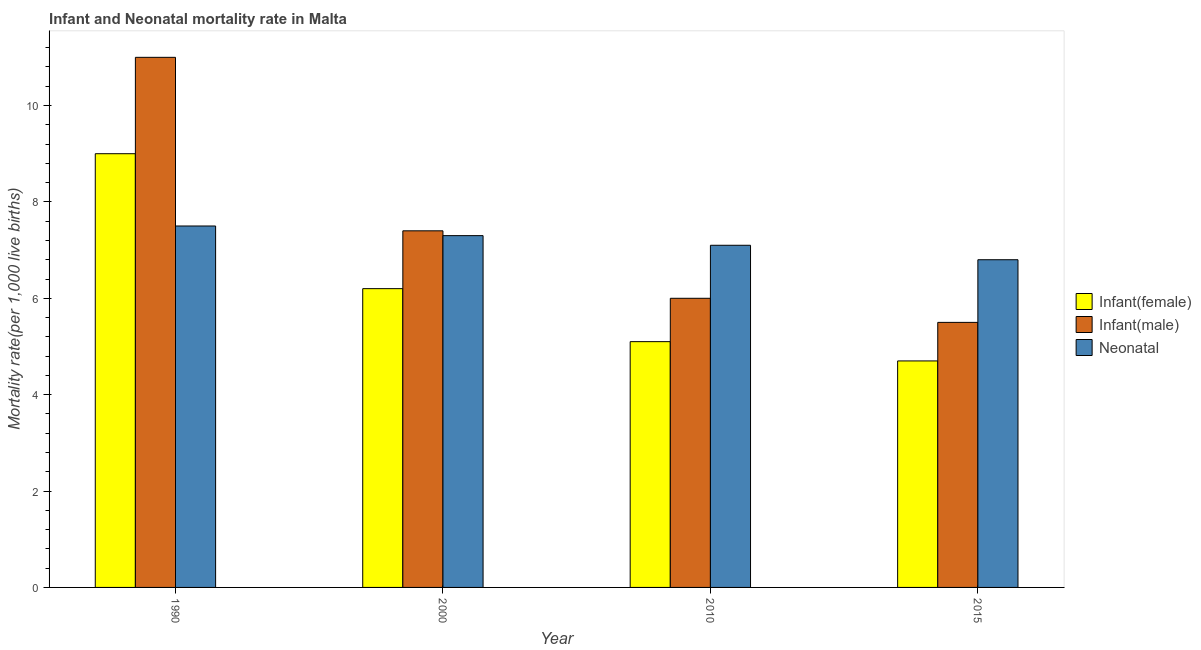How many groups of bars are there?
Make the answer very short. 4. Are the number of bars on each tick of the X-axis equal?
Offer a very short reply. Yes. How many bars are there on the 3rd tick from the right?
Make the answer very short. 3. What is the label of the 2nd group of bars from the left?
Make the answer very short. 2000. Across all years, what is the maximum infant mortality rate(female)?
Make the answer very short. 9. In which year was the infant mortality rate(male) minimum?
Your answer should be compact. 2015. What is the total neonatal mortality rate in the graph?
Give a very brief answer. 28.7. What is the difference between the infant mortality rate(male) in 2000 and that in 2015?
Give a very brief answer. 1.9. What is the difference between the neonatal mortality rate in 2000 and the infant mortality rate(male) in 1990?
Offer a very short reply. -0.2. What is the average infant mortality rate(male) per year?
Ensure brevity in your answer.  7.47. In the year 1990, what is the difference between the neonatal mortality rate and infant mortality rate(female)?
Give a very brief answer. 0. What is the ratio of the neonatal mortality rate in 1990 to that in 2000?
Give a very brief answer. 1.03. Is the infant mortality rate(female) in 1990 less than that in 2000?
Provide a short and direct response. No. What is the difference between the highest and the second highest neonatal mortality rate?
Provide a short and direct response. 0.2. What is the difference between the highest and the lowest infant mortality rate(male)?
Offer a terse response. 5.5. In how many years, is the infant mortality rate(female) greater than the average infant mortality rate(female) taken over all years?
Ensure brevity in your answer.  1. Is the sum of the neonatal mortality rate in 1990 and 2010 greater than the maximum infant mortality rate(female) across all years?
Your answer should be compact. Yes. What does the 2nd bar from the left in 2015 represents?
Offer a terse response. Infant(male). What does the 1st bar from the right in 2000 represents?
Offer a terse response. Neonatal . Are all the bars in the graph horizontal?
Give a very brief answer. No. How many years are there in the graph?
Your answer should be compact. 4. What is the difference between two consecutive major ticks on the Y-axis?
Give a very brief answer. 2. Are the values on the major ticks of Y-axis written in scientific E-notation?
Give a very brief answer. No. Does the graph contain any zero values?
Your answer should be compact. No. Does the graph contain grids?
Provide a succinct answer. No. Where does the legend appear in the graph?
Your answer should be very brief. Center right. How many legend labels are there?
Provide a short and direct response. 3. How are the legend labels stacked?
Offer a very short reply. Vertical. What is the title of the graph?
Give a very brief answer. Infant and Neonatal mortality rate in Malta. Does "Agricultural Nitrous Oxide" appear as one of the legend labels in the graph?
Offer a terse response. No. What is the label or title of the X-axis?
Provide a short and direct response. Year. What is the label or title of the Y-axis?
Ensure brevity in your answer.  Mortality rate(per 1,0 live births). What is the Mortality rate(per 1,000 live births) in Infant(male) in 1990?
Give a very brief answer. 11. What is the Mortality rate(per 1,000 live births) of Infant(male) in 2000?
Your response must be concise. 7.4. What is the Mortality rate(per 1,000 live births) of Neonatal  in 2000?
Give a very brief answer. 7.3. What is the Mortality rate(per 1,000 live births) of Infant(female) in 2010?
Your answer should be compact. 5.1. What is the Mortality rate(per 1,000 live births) in Infant(female) in 2015?
Your answer should be compact. 4.7. What is the Mortality rate(per 1,000 live births) of Infant(male) in 2015?
Your response must be concise. 5.5. What is the Mortality rate(per 1,000 live births) of Neonatal  in 2015?
Provide a short and direct response. 6.8. Across all years, what is the minimum Mortality rate(per 1,000 live births) in Infant(male)?
Ensure brevity in your answer.  5.5. Across all years, what is the minimum Mortality rate(per 1,000 live births) in Neonatal ?
Keep it short and to the point. 6.8. What is the total Mortality rate(per 1,000 live births) of Infant(male) in the graph?
Provide a succinct answer. 29.9. What is the total Mortality rate(per 1,000 live births) in Neonatal  in the graph?
Make the answer very short. 28.7. What is the difference between the Mortality rate(per 1,000 live births) of Infant(male) in 1990 and that in 2000?
Give a very brief answer. 3.6. What is the difference between the Mortality rate(per 1,000 live births) of Infant(female) in 1990 and that in 2010?
Offer a terse response. 3.9. What is the difference between the Mortality rate(per 1,000 live births) in Infant(male) in 1990 and that in 2010?
Provide a succinct answer. 5. What is the difference between the Mortality rate(per 1,000 live births) of Infant(female) in 1990 and that in 2015?
Provide a succinct answer. 4.3. What is the difference between the Mortality rate(per 1,000 live births) in Infant(male) in 1990 and that in 2015?
Ensure brevity in your answer.  5.5. What is the difference between the Mortality rate(per 1,000 live births) of Neonatal  in 1990 and that in 2015?
Keep it short and to the point. 0.7. What is the difference between the Mortality rate(per 1,000 live births) of Infant(female) in 2000 and that in 2010?
Give a very brief answer. 1.1. What is the difference between the Mortality rate(per 1,000 live births) of Neonatal  in 2000 and that in 2010?
Offer a terse response. 0.2. What is the difference between the Mortality rate(per 1,000 live births) of Infant(male) in 2000 and that in 2015?
Your response must be concise. 1.9. What is the difference between the Mortality rate(per 1,000 live births) of Neonatal  in 2010 and that in 2015?
Your answer should be very brief. 0.3. What is the difference between the Mortality rate(per 1,000 live births) of Infant(female) in 1990 and the Mortality rate(per 1,000 live births) of Infant(male) in 2000?
Provide a short and direct response. 1.6. What is the difference between the Mortality rate(per 1,000 live births) of Infant(female) in 1990 and the Mortality rate(per 1,000 live births) of Infant(male) in 2015?
Provide a succinct answer. 3.5. What is the difference between the Mortality rate(per 1,000 live births) of Infant(female) in 1990 and the Mortality rate(per 1,000 live births) of Neonatal  in 2015?
Provide a short and direct response. 2.2. What is the difference between the Mortality rate(per 1,000 live births) of Infant(male) in 2000 and the Mortality rate(per 1,000 live births) of Neonatal  in 2015?
Provide a succinct answer. 0.6. What is the difference between the Mortality rate(per 1,000 live births) in Infant(female) in 2010 and the Mortality rate(per 1,000 live births) in Neonatal  in 2015?
Give a very brief answer. -1.7. What is the average Mortality rate(per 1,000 live births) in Infant(female) per year?
Your answer should be very brief. 6.25. What is the average Mortality rate(per 1,000 live births) in Infant(male) per year?
Keep it short and to the point. 7.47. What is the average Mortality rate(per 1,000 live births) of Neonatal  per year?
Make the answer very short. 7.17. In the year 1990, what is the difference between the Mortality rate(per 1,000 live births) in Infant(female) and Mortality rate(per 1,000 live births) in Neonatal ?
Make the answer very short. 1.5. In the year 2000, what is the difference between the Mortality rate(per 1,000 live births) in Infant(female) and Mortality rate(per 1,000 live births) in Neonatal ?
Make the answer very short. -1.1. In the year 2010, what is the difference between the Mortality rate(per 1,000 live births) in Infant(female) and Mortality rate(per 1,000 live births) in Infant(male)?
Your response must be concise. -0.9. In the year 2010, what is the difference between the Mortality rate(per 1,000 live births) in Infant(female) and Mortality rate(per 1,000 live births) in Neonatal ?
Make the answer very short. -2. In the year 2015, what is the difference between the Mortality rate(per 1,000 live births) in Infant(male) and Mortality rate(per 1,000 live births) in Neonatal ?
Offer a very short reply. -1.3. What is the ratio of the Mortality rate(per 1,000 live births) of Infant(female) in 1990 to that in 2000?
Your response must be concise. 1.45. What is the ratio of the Mortality rate(per 1,000 live births) in Infant(male) in 1990 to that in 2000?
Keep it short and to the point. 1.49. What is the ratio of the Mortality rate(per 1,000 live births) in Neonatal  in 1990 to that in 2000?
Your answer should be very brief. 1.03. What is the ratio of the Mortality rate(per 1,000 live births) in Infant(female) in 1990 to that in 2010?
Give a very brief answer. 1.76. What is the ratio of the Mortality rate(per 1,000 live births) of Infant(male) in 1990 to that in 2010?
Offer a terse response. 1.83. What is the ratio of the Mortality rate(per 1,000 live births) of Neonatal  in 1990 to that in 2010?
Your response must be concise. 1.06. What is the ratio of the Mortality rate(per 1,000 live births) of Infant(female) in 1990 to that in 2015?
Provide a succinct answer. 1.91. What is the ratio of the Mortality rate(per 1,000 live births) in Neonatal  in 1990 to that in 2015?
Provide a short and direct response. 1.1. What is the ratio of the Mortality rate(per 1,000 live births) of Infant(female) in 2000 to that in 2010?
Offer a very short reply. 1.22. What is the ratio of the Mortality rate(per 1,000 live births) in Infant(male) in 2000 to that in 2010?
Make the answer very short. 1.23. What is the ratio of the Mortality rate(per 1,000 live births) in Neonatal  in 2000 to that in 2010?
Your response must be concise. 1.03. What is the ratio of the Mortality rate(per 1,000 live births) in Infant(female) in 2000 to that in 2015?
Keep it short and to the point. 1.32. What is the ratio of the Mortality rate(per 1,000 live births) in Infant(male) in 2000 to that in 2015?
Give a very brief answer. 1.35. What is the ratio of the Mortality rate(per 1,000 live births) in Neonatal  in 2000 to that in 2015?
Your answer should be very brief. 1.07. What is the ratio of the Mortality rate(per 1,000 live births) of Infant(female) in 2010 to that in 2015?
Provide a short and direct response. 1.09. What is the ratio of the Mortality rate(per 1,000 live births) in Neonatal  in 2010 to that in 2015?
Make the answer very short. 1.04. What is the difference between the highest and the second highest Mortality rate(per 1,000 live births) of Infant(female)?
Keep it short and to the point. 2.8. What is the difference between the highest and the second highest Mortality rate(per 1,000 live births) in Infant(male)?
Offer a terse response. 3.6. What is the difference between the highest and the lowest Mortality rate(per 1,000 live births) in Infant(female)?
Keep it short and to the point. 4.3. What is the difference between the highest and the lowest Mortality rate(per 1,000 live births) in Neonatal ?
Your response must be concise. 0.7. 